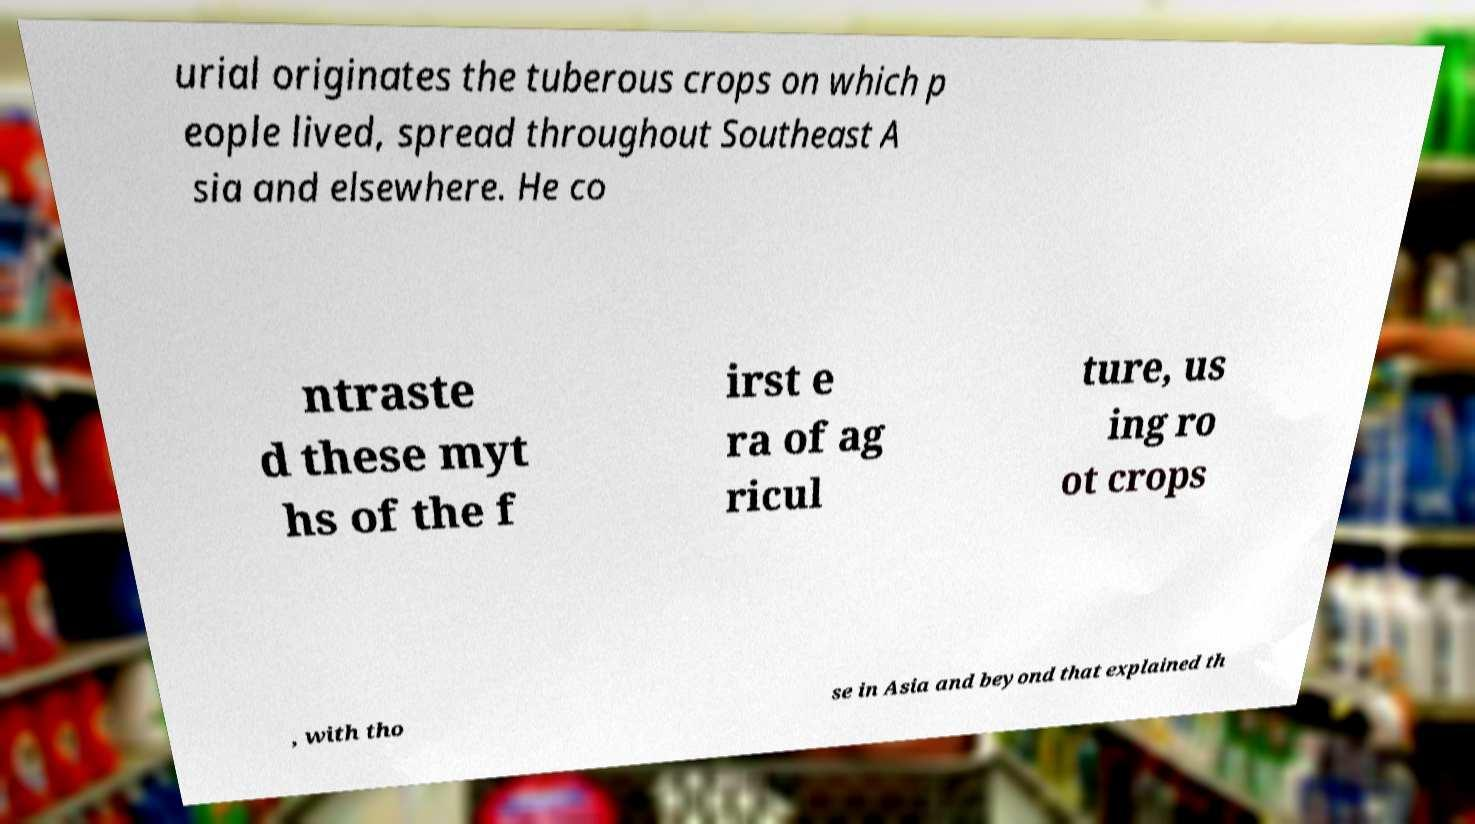Can you accurately transcribe the text from the provided image for me? urial originates the tuberous crops on which p eople lived, spread throughout Southeast A sia and elsewhere. He co ntraste d these myt hs of the f irst e ra of ag ricul ture, us ing ro ot crops , with tho se in Asia and beyond that explained th 